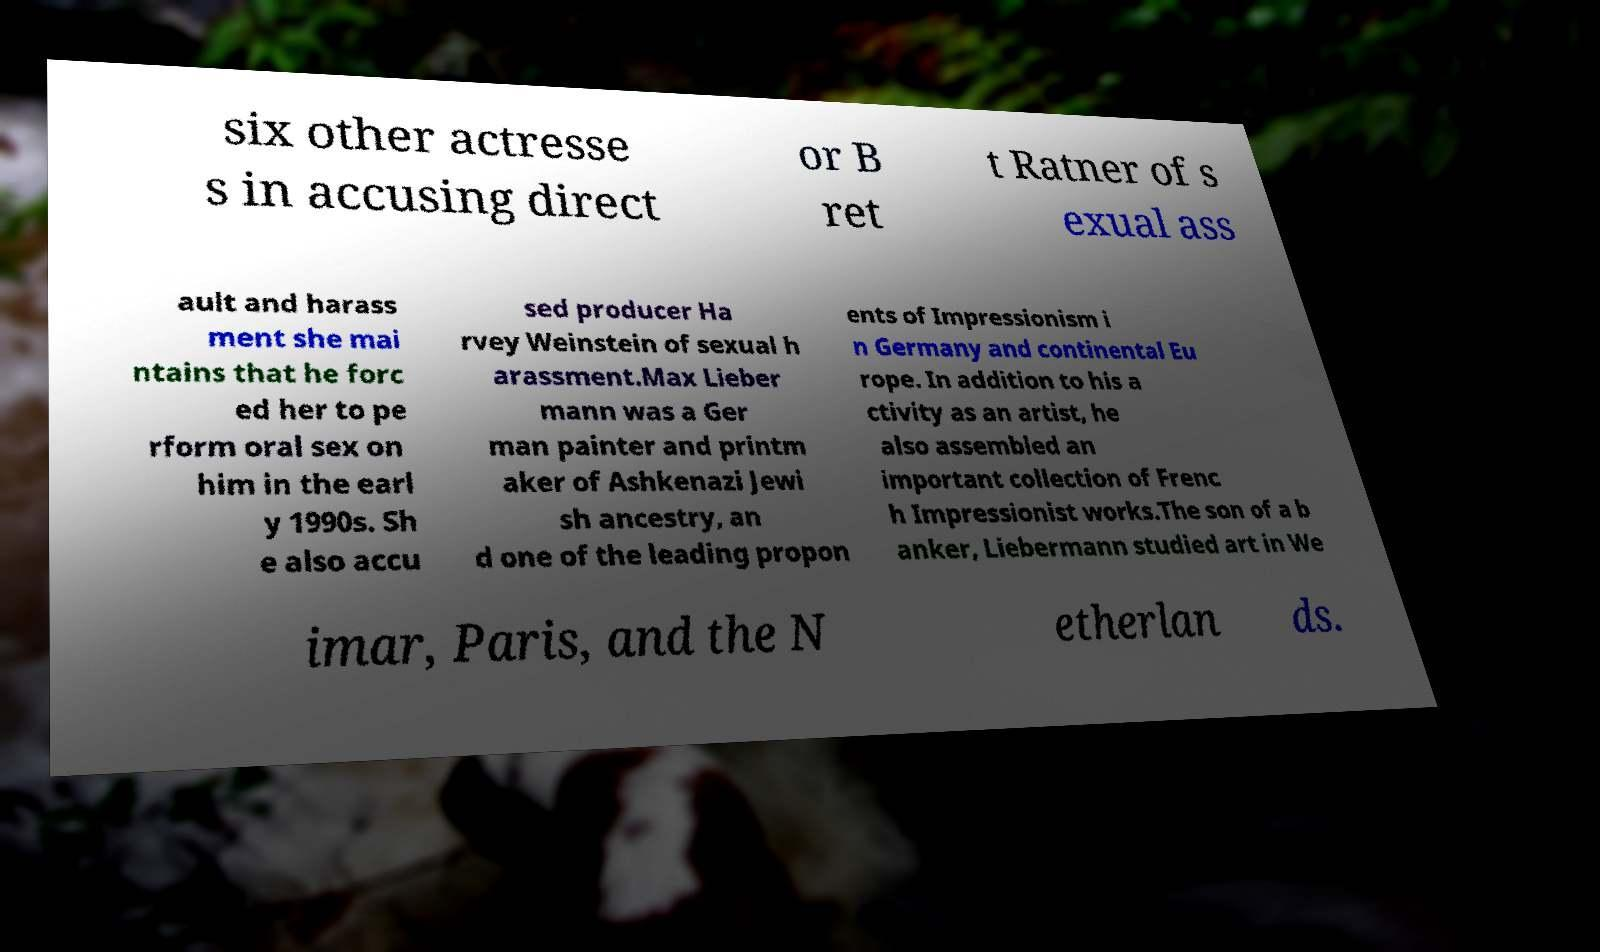Could you assist in decoding the text presented in this image and type it out clearly? six other actresse s in accusing direct or B ret t Ratner of s exual ass ault and harass ment she mai ntains that he forc ed her to pe rform oral sex on him in the earl y 1990s. Sh e also accu sed producer Ha rvey Weinstein of sexual h arassment.Max Lieber mann was a Ger man painter and printm aker of Ashkenazi Jewi sh ancestry, an d one of the leading propon ents of Impressionism i n Germany and continental Eu rope. In addition to his a ctivity as an artist, he also assembled an important collection of Frenc h Impressionist works.The son of a b anker, Liebermann studied art in We imar, Paris, and the N etherlan ds. 